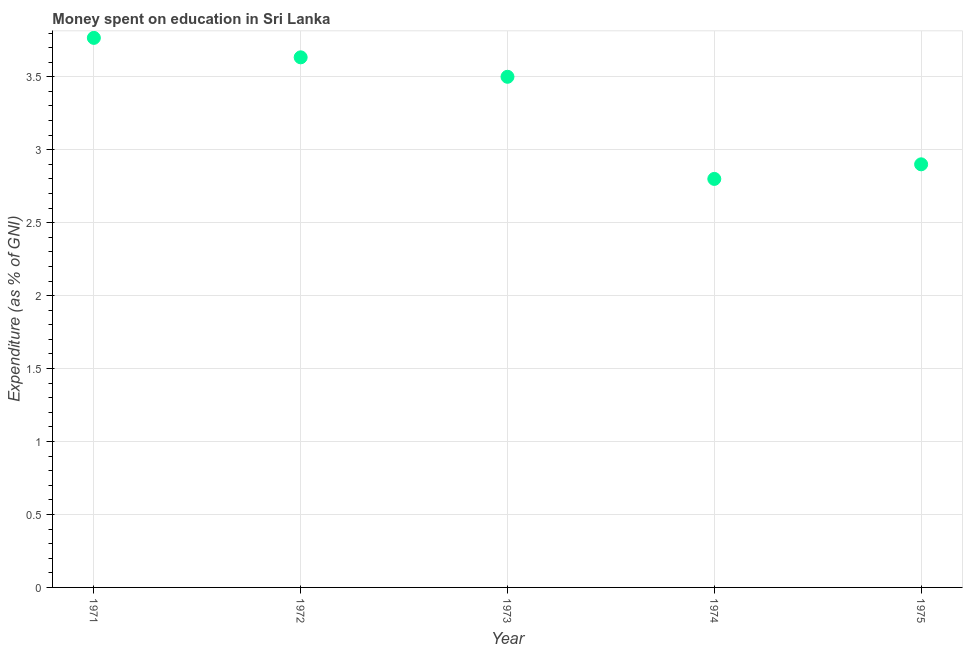Across all years, what is the maximum expenditure on education?
Provide a short and direct response. 3.77. Across all years, what is the minimum expenditure on education?
Offer a terse response. 2.8. In which year was the expenditure on education maximum?
Your answer should be very brief. 1971. In which year was the expenditure on education minimum?
Your answer should be compact. 1974. What is the sum of the expenditure on education?
Give a very brief answer. 16.6. What is the difference between the expenditure on education in 1973 and 1974?
Keep it short and to the point. 0.7. What is the average expenditure on education per year?
Give a very brief answer. 3.32. What is the median expenditure on education?
Your response must be concise. 3.5. What is the ratio of the expenditure on education in 1972 to that in 1975?
Offer a terse response. 1.25. Is the expenditure on education in 1971 less than that in 1974?
Your response must be concise. No. Is the difference between the expenditure on education in 1971 and 1975 greater than the difference between any two years?
Your answer should be compact. No. What is the difference between the highest and the second highest expenditure on education?
Make the answer very short. 0.13. Is the sum of the expenditure on education in 1971 and 1973 greater than the maximum expenditure on education across all years?
Your answer should be compact. Yes. What is the difference between the highest and the lowest expenditure on education?
Make the answer very short. 0.97. In how many years, is the expenditure on education greater than the average expenditure on education taken over all years?
Your answer should be compact. 3. How many years are there in the graph?
Keep it short and to the point. 5. What is the difference between two consecutive major ticks on the Y-axis?
Make the answer very short. 0.5. Does the graph contain grids?
Offer a very short reply. Yes. What is the title of the graph?
Keep it short and to the point. Money spent on education in Sri Lanka. What is the label or title of the Y-axis?
Offer a very short reply. Expenditure (as % of GNI). What is the Expenditure (as % of GNI) in 1971?
Offer a terse response. 3.77. What is the Expenditure (as % of GNI) in 1972?
Offer a terse response. 3.63. What is the Expenditure (as % of GNI) in 1974?
Offer a very short reply. 2.8. What is the Expenditure (as % of GNI) in 1975?
Your answer should be compact. 2.9. What is the difference between the Expenditure (as % of GNI) in 1971 and 1972?
Offer a very short reply. 0.13. What is the difference between the Expenditure (as % of GNI) in 1971 and 1973?
Your response must be concise. 0.27. What is the difference between the Expenditure (as % of GNI) in 1971 and 1974?
Keep it short and to the point. 0.97. What is the difference between the Expenditure (as % of GNI) in 1971 and 1975?
Offer a very short reply. 0.87. What is the difference between the Expenditure (as % of GNI) in 1972 and 1973?
Give a very brief answer. 0.13. What is the difference between the Expenditure (as % of GNI) in 1972 and 1974?
Give a very brief answer. 0.83. What is the difference between the Expenditure (as % of GNI) in 1972 and 1975?
Provide a short and direct response. 0.73. What is the difference between the Expenditure (as % of GNI) in 1973 and 1974?
Give a very brief answer. 0.7. What is the difference between the Expenditure (as % of GNI) in 1973 and 1975?
Provide a short and direct response. 0.6. What is the ratio of the Expenditure (as % of GNI) in 1971 to that in 1972?
Make the answer very short. 1.04. What is the ratio of the Expenditure (as % of GNI) in 1971 to that in 1973?
Your answer should be very brief. 1.08. What is the ratio of the Expenditure (as % of GNI) in 1971 to that in 1974?
Offer a terse response. 1.34. What is the ratio of the Expenditure (as % of GNI) in 1971 to that in 1975?
Provide a short and direct response. 1.3. What is the ratio of the Expenditure (as % of GNI) in 1972 to that in 1973?
Give a very brief answer. 1.04. What is the ratio of the Expenditure (as % of GNI) in 1972 to that in 1974?
Offer a very short reply. 1.3. What is the ratio of the Expenditure (as % of GNI) in 1972 to that in 1975?
Make the answer very short. 1.25. What is the ratio of the Expenditure (as % of GNI) in 1973 to that in 1975?
Ensure brevity in your answer.  1.21. What is the ratio of the Expenditure (as % of GNI) in 1974 to that in 1975?
Your response must be concise. 0.97. 